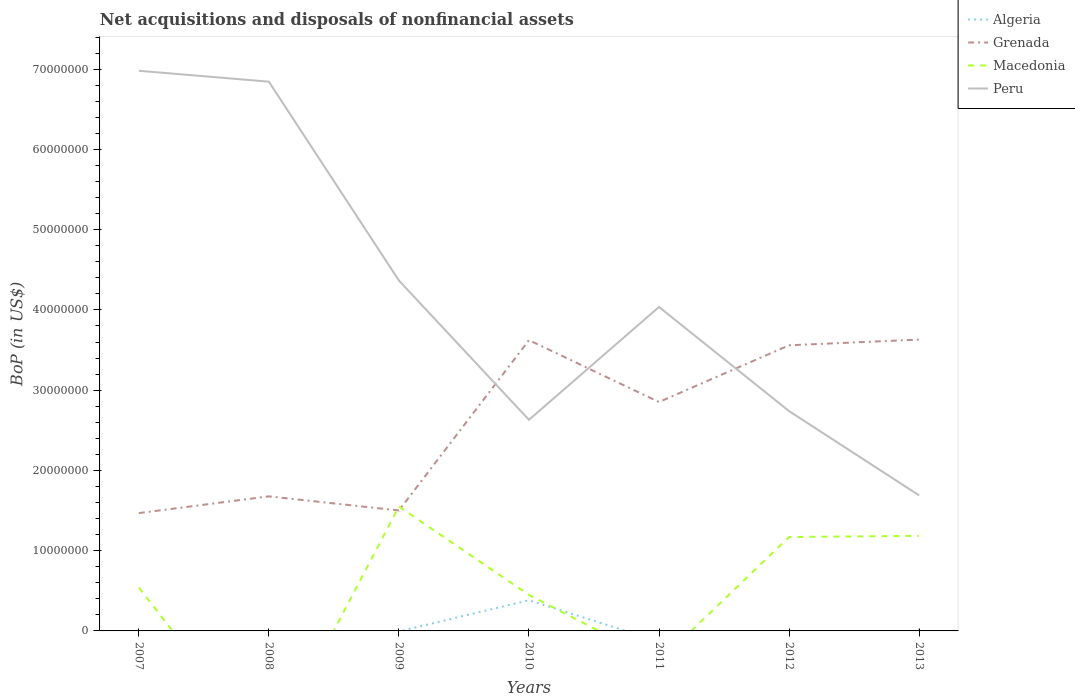How many different coloured lines are there?
Give a very brief answer. 4. Does the line corresponding to Macedonia intersect with the line corresponding to Grenada?
Provide a succinct answer. Yes. Across all years, what is the maximum Balance of Payments in Algeria?
Your answer should be compact. 0. What is the total Balance of Payments in Grenada in the graph?
Offer a terse response. 6.43e+05. What is the difference between the highest and the second highest Balance of Payments in Grenada?
Provide a short and direct response. 2.16e+07. What is the difference between the highest and the lowest Balance of Payments in Peru?
Provide a succinct answer. 3. Is the Balance of Payments in Grenada strictly greater than the Balance of Payments in Algeria over the years?
Offer a very short reply. No. How many years are there in the graph?
Provide a succinct answer. 7. Does the graph contain grids?
Give a very brief answer. No. Where does the legend appear in the graph?
Your response must be concise. Top right. How are the legend labels stacked?
Provide a short and direct response. Vertical. What is the title of the graph?
Provide a short and direct response. Net acquisitions and disposals of nonfinancial assets. Does "Tanzania" appear as one of the legend labels in the graph?
Make the answer very short. No. What is the label or title of the X-axis?
Make the answer very short. Years. What is the label or title of the Y-axis?
Give a very brief answer. BoP (in US$). What is the BoP (in US$) of Algeria in 2007?
Your answer should be very brief. 0. What is the BoP (in US$) in Grenada in 2007?
Offer a very short reply. 1.47e+07. What is the BoP (in US$) in Macedonia in 2007?
Keep it short and to the point. 5.40e+06. What is the BoP (in US$) of Peru in 2007?
Keep it short and to the point. 6.98e+07. What is the BoP (in US$) of Grenada in 2008?
Make the answer very short. 1.68e+07. What is the BoP (in US$) in Macedonia in 2008?
Offer a very short reply. 0. What is the BoP (in US$) of Peru in 2008?
Give a very brief answer. 6.84e+07. What is the BoP (in US$) of Grenada in 2009?
Your answer should be compact. 1.50e+07. What is the BoP (in US$) in Macedonia in 2009?
Offer a terse response. 1.55e+07. What is the BoP (in US$) of Peru in 2009?
Keep it short and to the point. 4.37e+07. What is the BoP (in US$) in Algeria in 2010?
Offer a terse response. 3.82e+06. What is the BoP (in US$) of Grenada in 2010?
Your answer should be compact. 3.62e+07. What is the BoP (in US$) in Macedonia in 2010?
Offer a terse response. 4.49e+06. What is the BoP (in US$) of Peru in 2010?
Your response must be concise. 2.63e+07. What is the BoP (in US$) of Algeria in 2011?
Provide a succinct answer. 0. What is the BoP (in US$) of Grenada in 2011?
Make the answer very short. 2.85e+07. What is the BoP (in US$) in Macedonia in 2011?
Provide a short and direct response. 0. What is the BoP (in US$) of Peru in 2011?
Provide a succinct answer. 4.04e+07. What is the BoP (in US$) in Algeria in 2012?
Give a very brief answer. 0. What is the BoP (in US$) in Grenada in 2012?
Offer a terse response. 3.56e+07. What is the BoP (in US$) in Macedonia in 2012?
Your answer should be very brief. 1.17e+07. What is the BoP (in US$) in Peru in 2012?
Offer a terse response. 2.74e+07. What is the BoP (in US$) of Algeria in 2013?
Offer a very short reply. 2.24e+05. What is the BoP (in US$) in Grenada in 2013?
Your answer should be compact. 3.63e+07. What is the BoP (in US$) of Macedonia in 2013?
Make the answer very short. 1.18e+07. What is the BoP (in US$) in Peru in 2013?
Your response must be concise. 1.69e+07. Across all years, what is the maximum BoP (in US$) of Algeria?
Offer a terse response. 3.82e+06. Across all years, what is the maximum BoP (in US$) in Grenada?
Give a very brief answer. 3.63e+07. Across all years, what is the maximum BoP (in US$) in Macedonia?
Provide a short and direct response. 1.55e+07. Across all years, what is the maximum BoP (in US$) in Peru?
Provide a succinct answer. 6.98e+07. Across all years, what is the minimum BoP (in US$) in Grenada?
Give a very brief answer. 1.47e+07. Across all years, what is the minimum BoP (in US$) of Macedonia?
Provide a short and direct response. 0. Across all years, what is the minimum BoP (in US$) of Peru?
Your response must be concise. 1.69e+07. What is the total BoP (in US$) of Algeria in the graph?
Offer a terse response. 4.05e+06. What is the total BoP (in US$) of Grenada in the graph?
Your answer should be compact. 1.83e+08. What is the total BoP (in US$) of Macedonia in the graph?
Provide a short and direct response. 4.89e+07. What is the total BoP (in US$) in Peru in the graph?
Offer a very short reply. 2.93e+08. What is the difference between the BoP (in US$) of Grenada in 2007 and that in 2008?
Your answer should be compact. -2.09e+06. What is the difference between the BoP (in US$) in Peru in 2007 and that in 2008?
Make the answer very short. 1.36e+06. What is the difference between the BoP (in US$) in Grenada in 2007 and that in 2009?
Ensure brevity in your answer.  -3.27e+05. What is the difference between the BoP (in US$) of Macedonia in 2007 and that in 2009?
Offer a very short reply. -1.01e+07. What is the difference between the BoP (in US$) in Peru in 2007 and that in 2009?
Give a very brief answer. 2.61e+07. What is the difference between the BoP (in US$) of Grenada in 2007 and that in 2010?
Your response must be concise. -2.16e+07. What is the difference between the BoP (in US$) of Macedonia in 2007 and that in 2010?
Your response must be concise. 9.14e+05. What is the difference between the BoP (in US$) in Peru in 2007 and that in 2010?
Offer a very short reply. 4.35e+07. What is the difference between the BoP (in US$) in Grenada in 2007 and that in 2011?
Ensure brevity in your answer.  -1.38e+07. What is the difference between the BoP (in US$) in Peru in 2007 and that in 2011?
Keep it short and to the point. 2.94e+07. What is the difference between the BoP (in US$) in Grenada in 2007 and that in 2012?
Provide a succinct answer. -2.09e+07. What is the difference between the BoP (in US$) of Macedonia in 2007 and that in 2012?
Ensure brevity in your answer.  -6.30e+06. What is the difference between the BoP (in US$) of Peru in 2007 and that in 2012?
Your answer should be very brief. 4.24e+07. What is the difference between the BoP (in US$) of Grenada in 2007 and that in 2013?
Offer a very short reply. -2.16e+07. What is the difference between the BoP (in US$) in Macedonia in 2007 and that in 2013?
Offer a terse response. -6.45e+06. What is the difference between the BoP (in US$) of Peru in 2007 and that in 2013?
Make the answer very short. 5.29e+07. What is the difference between the BoP (in US$) of Grenada in 2008 and that in 2009?
Make the answer very short. 1.76e+06. What is the difference between the BoP (in US$) in Peru in 2008 and that in 2009?
Ensure brevity in your answer.  2.48e+07. What is the difference between the BoP (in US$) of Grenada in 2008 and that in 2010?
Make the answer very short. -1.95e+07. What is the difference between the BoP (in US$) in Peru in 2008 and that in 2010?
Give a very brief answer. 4.21e+07. What is the difference between the BoP (in US$) of Grenada in 2008 and that in 2011?
Keep it short and to the point. -1.18e+07. What is the difference between the BoP (in US$) in Peru in 2008 and that in 2011?
Your response must be concise. 2.81e+07. What is the difference between the BoP (in US$) of Grenada in 2008 and that in 2012?
Your answer should be compact. -1.88e+07. What is the difference between the BoP (in US$) of Peru in 2008 and that in 2012?
Offer a terse response. 4.10e+07. What is the difference between the BoP (in US$) of Grenada in 2008 and that in 2013?
Provide a short and direct response. -1.95e+07. What is the difference between the BoP (in US$) in Peru in 2008 and that in 2013?
Give a very brief answer. 5.16e+07. What is the difference between the BoP (in US$) of Grenada in 2009 and that in 2010?
Your answer should be compact. -2.12e+07. What is the difference between the BoP (in US$) of Macedonia in 2009 and that in 2010?
Offer a terse response. 1.10e+07. What is the difference between the BoP (in US$) in Peru in 2009 and that in 2010?
Provide a succinct answer. 1.74e+07. What is the difference between the BoP (in US$) in Grenada in 2009 and that in 2011?
Your answer should be compact. -1.35e+07. What is the difference between the BoP (in US$) in Peru in 2009 and that in 2011?
Ensure brevity in your answer.  3.30e+06. What is the difference between the BoP (in US$) in Grenada in 2009 and that in 2012?
Give a very brief answer. -2.06e+07. What is the difference between the BoP (in US$) of Macedonia in 2009 and that in 2012?
Provide a short and direct response. 3.81e+06. What is the difference between the BoP (in US$) of Peru in 2009 and that in 2012?
Your response must be concise. 1.63e+07. What is the difference between the BoP (in US$) of Grenada in 2009 and that in 2013?
Your response must be concise. -2.13e+07. What is the difference between the BoP (in US$) in Macedonia in 2009 and that in 2013?
Give a very brief answer. 3.66e+06. What is the difference between the BoP (in US$) of Peru in 2009 and that in 2013?
Your response must be concise. 2.68e+07. What is the difference between the BoP (in US$) of Grenada in 2010 and that in 2011?
Keep it short and to the point. 7.71e+06. What is the difference between the BoP (in US$) of Peru in 2010 and that in 2011?
Give a very brief answer. -1.41e+07. What is the difference between the BoP (in US$) in Grenada in 2010 and that in 2012?
Make the answer very short. 6.43e+05. What is the difference between the BoP (in US$) in Macedonia in 2010 and that in 2012?
Ensure brevity in your answer.  -7.22e+06. What is the difference between the BoP (in US$) in Peru in 2010 and that in 2012?
Your answer should be compact. -1.09e+06. What is the difference between the BoP (in US$) of Algeria in 2010 and that in 2013?
Keep it short and to the point. 3.60e+06. What is the difference between the BoP (in US$) of Grenada in 2010 and that in 2013?
Make the answer very short. -6.92e+04. What is the difference between the BoP (in US$) in Macedonia in 2010 and that in 2013?
Your answer should be compact. -7.36e+06. What is the difference between the BoP (in US$) in Peru in 2010 and that in 2013?
Make the answer very short. 9.42e+06. What is the difference between the BoP (in US$) in Grenada in 2011 and that in 2012?
Your answer should be very brief. -7.07e+06. What is the difference between the BoP (in US$) in Peru in 2011 and that in 2012?
Provide a succinct answer. 1.30e+07. What is the difference between the BoP (in US$) in Grenada in 2011 and that in 2013?
Your answer should be very brief. -7.78e+06. What is the difference between the BoP (in US$) of Peru in 2011 and that in 2013?
Keep it short and to the point. 2.35e+07. What is the difference between the BoP (in US$) in Grenada in 2012 and that in 2013?
Your answer should be compact. -7.12e+05. What is the difference between the BoP (in US$) of Macedonia in 2012 and that in 2013?
Give a very brief answer. -1.45e+05. What is the difference between the BoP (in US$) of Peru in 2012 and that in 2013?
Provide a short and direct response. 1.05e+07. What is the difference between the BoP (in US$) of Grenada in 2007 and the BoP (in US$) of Peru in 2008?
Provide a succinct answer. -5.38e+07. What is the difference between the BoP (in US$) in Macedonia in 2007 and the BoP (in US$) in Peru in 2008?
Offer a very short reply. -6.30e+07. What is the difference between the BoP (in US$) in Grenada in 2007 and the BoP (in US$) in Macedonia in 2009?
Ensure brevity in your answer.  -8.25e+05. What is the difference between the BoP (in US$) of Grenada in 2007 and the BoP (in US$) of Peru in 2009?
Make the answer very short. -2.90e+07. What is the difference between the BoP (in US$) in Macedonia in 2007 and the BoP (in US$) in Peru in 2009?
Give a very brief answer. -3.83e+07. What is the difference between the BoP (in US$) in Grenada in 2007 and the BoP (in US$) in Macedonia in 2010?
Keep it short and to the point. 1.02e+07. What is the difference between the BoP (in US$) in Grenada in 2007 and the BoP (in US$) in Peru in 2010?
Make the answer very short. -1.16e+07. What is the difference between the BoP (in US$) in Macedonia in 2007 and the BoP (in US$) in Peru in 2010?
Offer a very short reply. -2.09e+07. What is the difference between the BoP (in US$) in Grenada in 2007 and the BoP (in US$) in Peru in 2011?
Ensure brevity in your answer.  -2.57e+07. What is the difference between the BoP (in US$) in Macedonia in 2007 and the BoP (in US$) in Peru in 2011?
Keep it short and to the point. -3.50e+07. What is the difference between the BoP (in US$) of Grenada in 2007 and the BoP (in US$) of Macedonia in 2012?
Make the answer very short. 2.98e+06. What is the difference between the BoP (in US$) in Grenada in 2007 and the BoP (in US$) in Peru in 2012?
Your response must be concise. -1.27e+07. What is the difference between the BoP (in US$) in Macedonia in 2007 and the BoP (in US$) in Peru in 2012?
Your response must be concise. -2.20e+07. What is the difference between the BoP (in US$) in Grenada in 2007 and the BoP (in US$) in Macedonia in 2013?
Keep it short and to the point. 2.84e+06. What is the difference between the BoP (in US$) of Grenada in 2007 and the BoP (in US$) of Peru in 2013?
Provide a short and direct response. -2.21e+06. What is the difference between the BoP (in US$) of Macedonia in 2007 and the BoP (in US$) of Peru in 2013?
Ensure brevity in your answer.  -1.15e+07. What is the difference between the BoP (in US$) of Grenada in 2008 and the BoP (in US$) of Macedonia in 2009?
Provide a short and direct response. 1.26e+06. What is the difference between the BoP (in US$) in Grenada in 2008 and the BoP (in US$) in Peru in 2009?
Provide a succinct answer. -2.69e+07. What is the difference between the BoP (in US$) of Grenada in 2008 and the BoP (in US$) of Macedonia in 2010?
Your answer should be very brief. 1.23e+07. What is the difference between the BoP (in US$) in Grenada in 2008 and the BoP (in US$) in Peru in 2010?
Offer a terse response. -9.54e+06. What is the difference between the BoP (in US$) in Grenada in 2008 and the BoP (in US$) in Peru in 2011?
Your answer should be compact. -2.36e+07. What is the difference between the BoP (in US$) of Grenada in 2008 and the BoP (in US$) of Macedonia in 2012?
Your answer should be compact. 5.07e+06. What is the difference between the BoP (in US$) in Grenada in 2008 and the BoP (in US$) in Peru in 2012?
Your response must be concise. -1.06e+07. What is the difference between the BoP (in US$) in Grenada in 2008 and the BoP (in US$) in Macedonia in 2013?
Ensure brevity in your answer.  4.92e+06. What is the difference between the BoP (in US$) of Grenada in 2008 and the BoP (in US$) of Peru in 2013?
Offer a very short reply. -1.20e+05. What is the difference between the BoP (in US$) of Grenada in 2009 and the BoP (in US$) of Macedonia in 2010?
Make the answer very short. 1.05e+07. What is the difference between the BoP (in US$) in Grenada in 2009 and the BoP (in US$) in Peru in 2010?
Your response must be concise. -1.13e+07. What is the difference between the BoP (in US$) of Macedonia in 2009 and the BoP (in US$) of Peru in 2010?
Your answer should be compact. -1.08e+07. What is the difference between the BoP (in US$) in Grenada in 2009 and the BoP (in US$) in Peru in 2011?
Provide a succinct answer. -2.54e+07. What is the difference between the BoP (in US$) in Macedonia in 2009 and the BoP (in US$) in Peru in 2011?
Offer a terse response. -2.49e+07. What is the difference between the BoP (in US$) in Grenada in 2009 and the BoP (in US$) in Macedonia in 2012?
Your answer should be compact. 3.31e+06. What is the difference between the BoP (in US$) in Grenada in 2009 and the BoP (in US$) in Peru in 2012?
Offer a terse response. -1.24e+07. What is the difference between the BoP (in US$) in Macedonia in 2009 and the BoP (in US$) in Peru in 2012?
Offer a terse response. -1.19e+07. What is the difference between the BoP (in US$) of Grenada in 2009 and the BoP (in US$) of Macedonia in 2013?
Your answer should be very brief. 3.16e+06. What is the difference between the BoP (in US$) of Grenada in 2009 and the BoP (in US$) of Peru in 2013?
Your answer should be compact. -1.88e+06. What is the difference between the BoP (in US$) of Macedonia in 2009 and the BoP (in US$) of Peru in 2013?
Offer a terse response. -1.38e+06. What is the difference between the BoP (in US$) in Algeria in 2010 and the BoP (in US$) in Grenada in 2011?
Keep it short and to the point. -2.47e+07. What is the difference between the BoP (in US$) of Algeria in 2010 and the BoP (in US$) of Peru in 2011?
Your response must be concise. -3.65e+07. What is the difference between the BoP (in US$) in Grenada in 2010 and the BoP (in US$) in Peru in 2011?
Your answer should be very brief. -4.13e+06. What is the difference between the BoP (in US$) in Macedonia in 2010 and the BoP (in US$) in Peru in 2011?
Ensure brevity in your answer.  -3.59e+07. What is the difference between the BoP (in US$) of Algeria in 2010 and the BoP (in US$) of Grenada in 2012?
Offer a very short reply. -3.18e+07. What is the difference between the BoP (in US$) of Algeria in 2010 and the BoP (in US$) of Macedonia in 2012?
Keep it short and to the point. -7.88e+06. What is the difference between the BoP (in US$) in Algeria in 2010 and the BoP (in US$) in Peru in 2012?
Ensure brevity in your answer.  -2.36e+07. What is the difference between the BoP (in US$) of Grenada in 2010 and the BoP (in US$) of Macedonia in 2012?
Your answer should be very brief. 2.45e+07. What is the difference between the BoP (in US$) in Grenada in 2010 and the BoP (in US$) in Peru in 2012?
Your response must be concise. 8.84e+06. What is the difference between the BoP (in US$) of Macedonia in 2010 and the BoP (in US$) of Peru in 2012?
Give a very brief answer. -2.29e+07. What is the difference between the BoP (in US$) in Algeria in 2010 and the BoP (in US$) in Grenada in 2013?
Give a very brief answer. -3.25e+07. What is the difference between the BoP (in US$) in Algeria in 2010 and the BoP (in US$) in Macedonia in 2013?
Offer a very short reply. -8.02e+06. What is the difference between the BoP (in US$) of Algeria in 2010 and the BoP (in US$) of Peru in 2013?
Keep it short and to the point. -1.31e+07. What is the difference between the BoP (in US$) in Grenada in 2010 and the BoP (in US$) in Macedonia in 2013?
Give a very brief answer. 2.44e+07. What is the difference between the BoP (in US$) of Grenada in 2010 and the BoP (in US$) of Peru in 2013?
Keep it short and to the point. 1.93e+07. What is the difference between the BoP (in US$) in Macedonia in 2010 and the BoP (in US$) in Peru in 2013?
Offer a terse response. -1.24e+07. What is the difference between the BoP (in US$) in Grenada in 2011 and the BoP (in US$) in Macedonia in 2012?
Your response must be concise. 1.68e+07. What is the difference between the BoP (in US$) in Grenada in 2011 and the BoP (in US$) in Peru in 2012?
Provide a short and direct response. 1.13e+06. What is the difference between the BoP (in US$) of Grenada in 2011 and the BoP (in US$) of Macedonia in 2013?
Your answer should be very brief. 1.67e+07. What is the difference between the BoP (in US$) of Grenada in 2011 and the BoP (in US$) of Peru in 2013?
Ensure brevity in your answer.  1.16e+07. What is the difference between the BoP (in US$) of Grenada in 2012 and the BoP (in US$) of Macedonia in 2013?
Provide a succinct answer. 2.37e+07. What is the difference between the BoP (in US$) in Grenada in 2012 and the BoP (in US$) in Peru in 2013?
Provide a short and direct response. 1.87e+07. What is the difference between the BoP (in US$) in Macedonia in 2012 and the BoP (in US$) in Peru in 2013?
Offer a very short reply. -5.19e+06. What is the average BoP (in US$) of Algeria per year?
Make the answer very short. 5.78e+05. What is the average BoP (in US$) of Grenada per year?
Ensure brevity in your answer.  2.62e+07. What is the average BoP (in US$) of Macedonia per year?
Provide a short and direct response. 6.99e+06. What is the average BoP (in US$) in Peru per year?
Your answer should be compact. 4.18e+07. In the year 2007, what is the difference between the BoP (in US$) of Grenada and BoP (in US$) of Macedonia?
Provide a succinct answer. 9.28e+06. In the year 2007, what is the difference between the BoP (in US$) of Grenada and BoP (in US$) of Peru?
Offer a terse response. -5.51e+07. In the year 2007, what is the difference between the BoP (in US$) in Macedonia and BoP (in US$) in Peru?
Ensure brevity in your answer.  -6.44e+07. In the year 2008, what is the difference between the BoP (in US$) of Grenada and BoP (in US$) of Peru?
Your response must be concise. -5.17e+07. In the year 2009, what is the difference between the BoP (in US$) in Grenada and BoP (in US$) in Macedonia?
Your answer should be compact. -4.97e+05. In the year 2009, what is the difference between the BoP (in US$) of Grenada and BoP (in US$) of Peru?
Ensure brevity in your answer.  -2.87e+07. In the year 2009, what is the difference between the BoP (in US$) in Macedonia and BoP (in US$) in Peru?
Ensure brevity in your answer.  -2.82e+07. In the year 2010, what is the difference between the BoP (in US$) in Algeria and BoP (in US$) in Grenada?
Offer a very short reply. -3.24e+07. In the year 2010, what is the difference between the BoP (in US$) of Algeria and BoP (in US$) of Macedonia?
Keep it short and to the point. -6.63e+05. In the year 2010, what is the difference between the BoP (in US$) in Algeria and BoP (in US$) in Peru?
Your answer should be compact. -2.25e+07. In the year 2010, what is the difference between the BoP (in US$) of Grenada and BoP (in US$) of Macedonia?
Give a very brief answer. 3.17e+07. In the year 2010, what is the difference between the BoP (in US$) of Grenada and BoP (in US$) of Peru?
Provide a succinct answer. 9.93e+06. In the year 2010, what is the difference between the BoP (in US$) in Macedonia and BoP (in US$) in Peru?
Provide a succinct answer. -2.18e+07. In the year 2011, what is the difference between the BoP (in US$) in Grenada and BoP (in US$) in Peru?
Keep it short and to the point. -1.18e+07. In the year 2012, what is the difference between the BoP (in US$) in Grenada and BoP (in US$) in Macedonia?
Keep it short and to the point. 2.39e+07. In the year 2012, what is the difference between the BoP (in US$) in Grenada and BoP (in US$) in Peru?
Provide a succinct answer. 8.20e+06. In the year 2012, what is the difference between the BoP (in US$) of Macedonia and BoP (in US$) of Peru?
Your answer should be compact. -1.57e+07. In the year 2013, what is the difference between the BoP (in US$) of Algeria and BoP (in US$) of Grenada?
Give a very brief answer. -3.61e+07. In the year 2013, what is the difference between the BoP (in US$) in Algeria and BoP (in US$) in Macedonia?
Provide a succinct answer. -1.16e+07. In the year 2013, what is the difference between the BoP (in US$) of Algeria and BoP (in US$) of Peru?
Your answer should be very brief. -1.67e+07. In the year 2013, what is the difference between the BoP (in US$) in Grenada and BoP (in US$) in Macedonia?
Your answer should be very brief. 2.45e+07. In the year 2013, what is the difference between the BoP (in US$) in Grenada and BoP (in US$) in Peru?
Your response must be concise. 1.94e+07. In the year 2013, what is the difference between the BoP (in US$) of Macedonia and BoP (in US$) of Peru?
Provide a succinct answer. -5.04e+06. What is the ratio of the BoP (in US$) in Grenada in 2007 to that in 2008?
Your answer should be very brief. 0.88. What is the ratio of the BoP (in US$) of Peru in 2007 to that in 2008?
Your answer should be very brief. 1.02. What is the ratio of the BoP (in US$) of Grenada in 2007 to that in 2009?
Keep it short and to the point. 0.98. What is the ratio of the BoP (in US$) of Macedonia in 2007 to that in 2009?
Keep it short and to the point. 0.35. What is the ratio of the BoP (in US$) of Peru in 2007 to that in 2009?
Make the answer very short. 1.6. What is the ratio of the BoP (in US$) in Grenada in 2007 to that in 2010?
Offer a very short reply. 0.41. What is the ratio of the BoP (in US$) in Macedonia in 2007 to that in 2010?
Keep it short and to the point. 1.2. What is the ratio of the BoP (in US$) of Peru in 2007 to that in 2010?
Offer a very short reply. 2.65. What is the ratio of the BoP (in US$) in Grenada in 2007 to that in 2011?
Ensure brevity in your answer.  0.51. What is the ratio of the BoP (in US$) in Peru in 2007 to that in 2011?
Offer a very short reply. 1.73. What is the ratio of the BoP (in US$) of Grenada in 2007 to that in 2012?
Ensure brevity in your answer.  0.41. What is the ratio of the BoP (in US$) of Macedonia in 2007 to that in 2012?
Provide a succinct answer. 0.46. What is the ratio of the BoP (in US$) in Peru in 2007 to that in 2012?
Your response must be concise. 2.55. What is the ratio of the BoP (in US$) in Grenada in 2007 to that in 2013?
Your response must be concise. 0.4. What is the ratio of the BoP (in US$) in Macedonia in 2007 to that in 2013?
Your answer should be very brief. 0.46. What is the ratio of the BoP (in US$) in Peru in 2007 to that in 2013?
Your answer should be very brief. 4.13. What is the ratio of the BoP (in US$) in Grenada in 2008 to that in 2009?
Make the answer very short. 1.12. What is the ratio of the BoP (in US$) of Peru in 2008 to that in 2009?
Offer a very short reply. 1.57. What is the ratio of the BoP (in US$) of Grenada in 2008 to that in 2010?
Offer a terse response. 0.46. What is the ratio of the BoP (in US$) of Peru in 2008 to that in 2010?
Provide a succinct answer. 2.6. What is the ratio of the BoP (in US$) of Grenada in 2008 to that in 2011?
Make the answer very short. 0.59. What is the ratio of the BoP (in US$) in Peru in 2008 to that in 2011?
Keep it short and to the point. 1.7. What is the ratio of the BoP (in US$) of Grenada in 2008 to that in 2012?
Provide a short and direct response. 0.47. What is the ratio of the BoP (in US$) of Peru in 2008 to that in 2012?
Make the answer very short. 2.5. What is the ratio of the BoP (in US$) of Grenada in 2008 to that in 2013?
Your answer should be very brief. 0.46. What is the ratio of the BoP (in US$) in Peru in 2008 to that in 2013?
Offer a very short reply. 4.05. What is the ratio of the BoP (in US$) of Grenada in 2009 to that in 2010?
Ensure brevity in your answer.  0.41. What is the ratio of the BoP (in US$) in Macedonia in 2009 to that in 2010?
Offer a terse response. 3.46. What is the ratio of the BoP (in US$) of Peru in 2009 to that in 2010?
Provide a succinct answer. 1.66. What is the ratio of the BoP (in US$) in Grenada in 2009 to that in 2011?
Give a very brief answer. 0.53. What is the ratio of the BoP (in US$) in Peru in 2009 to that in 2011?
Give a very brief answer. 1.08. What is the ratio of the BoP (in US$) of Grenada in 2009 to that in 2012?
Ensure brevity in your answer.  0.42. What is the ratio of the BoP (in US$) of Macedonia in 2009 to that in 2012?
Ensure brevity in your answer.  1.33. What is the ratio of the BoP (in US$) of Peru in 2009 to that in 2012?
Your answer should be very brief. 1.59. What is the ratio of the BoP (in US$) in Grenada in 2009 to that in 2013?
Provide a short and direct response. 0.41. What is the ratio of the BoP (in US$) of Macedonia in 2009 to that in 2013?
Keep it short and to the point. 1.31. What is the ratio of the BoP (in US$) in Peru in 2009 to that in 2013?
Make the answer very short. 2.59. What is the ratio of the BoP (in US$) of Grenada in 2010 to that in 2011?
Provide a succinct answer. 1.27. What is the ratio of the BoP (in US$) of Peru in 2010 to that in 2011?
Offer a very short reply. 0.65. What is the ratio of the BoP (in US$) of Grenada in 2010 to that in 2012?
Offer a terse response. 1.02. What is the ratio of the BoP (in US$) of Macedonia in 2010 to that in 2012?
Your response must be concise. 0.38. What is the ratio of the BoP (in US$) in Peru in 2010 to that in 2012?
Your response must be concise. 0.96. What is the ratio of the BoP (in US$) in Algeria in 2010 to that in 2013?
Give a very brief answer. 17.08. What is the ratio of the BoP (in US$) in Grenada in 2010 to that in 2013?
Keep it short and to the point. 1. What is the ratio of the BoP (in US$) in Macedonia in 2010 to that in 2013?
Offer a terse response. 0.38. What is the ratio of the BoP (in US$) in Peru in 2010 to that in 2013?
Give a very brief answer. 1.56. What is the ratio of the BoP (in US$) in Grenada in 2011 to that in 2012?
Make the answer very short. 0.8. What is the ratio of the BoP (in US$) in Peru in 2011 to that in 2012?
Provide a succinct answer. 1.47. What is the ratio of the BoP (in US$) in Grenada in 2011 to that in 2013?
Your answer should be compact. 0.79. What is the ratio of the BoP (in US$) of Peru in 2011 to that in 2013?
Provide a short and direct response. 2.39. What is the ratio of the BoP (in US$) in Grenada in 2012 to that in 2013?
Give a very brief answer. 0.98. What is the ratio of the BoP (in US$) of Macedonia in 2012 to that in 2013?
Provide a short and direct response. 0.99. What is the ratio of the BoP (in US$) in Peru in 2012 to that in 2013?
Keep it short and to the point. 1.62. What is the difference between the highest and the second highest BoP (in US$) of Grenada?
Make the answer very short. 6.92e+04. What is the difference between the highest and the second highest BoP (in US$) of Macedonia?
Provide a succinct answer. 3.66e+06. What is the difference between the highest and the second highest BoP (in US$) of Peru?
Offer a terse response. 1.36e+06. What is the difference between the highest and the lowest BoP (in US$) of Algeria?
Ensure brevity in your answer.  3.82e+06. What is the difference between the highest and the lowest BoP (in US$) of Grenada?
Offer a terse response. 2.16e+07. What is the difference between the highest and the lowest BoP (in US$) in Macedonia?
Provide a succinct answer. 1.55e+07. What is the difference between the highest and the lowest BoP (in US$) in Peru?
Provide a short and direct response. 5.29e+07. 